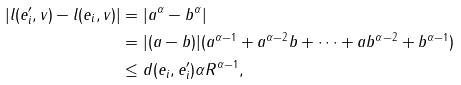Convert formula to latex. <formula><loc_0><loc_0><loc_500><loc_500>| l ( e ^ { \prime } _ { i } , v ) - l ( e _ { i } , v ) | & = | a ^ { \alpha } - b ^ { \alpha } | \\ & = | ( a - b ) | ( a ^ { \alpha - 1 } + a ^ { \alpha - 2 } b + \cdots + a b ^ { \alpha - 2 } + b ^ { \alpha - 1 } ) \\ & \leq d ( e _ { i } , e ^ { \prime } _ { i } ) \alpha R ^ { \alpha - 1 } ,</formula> 